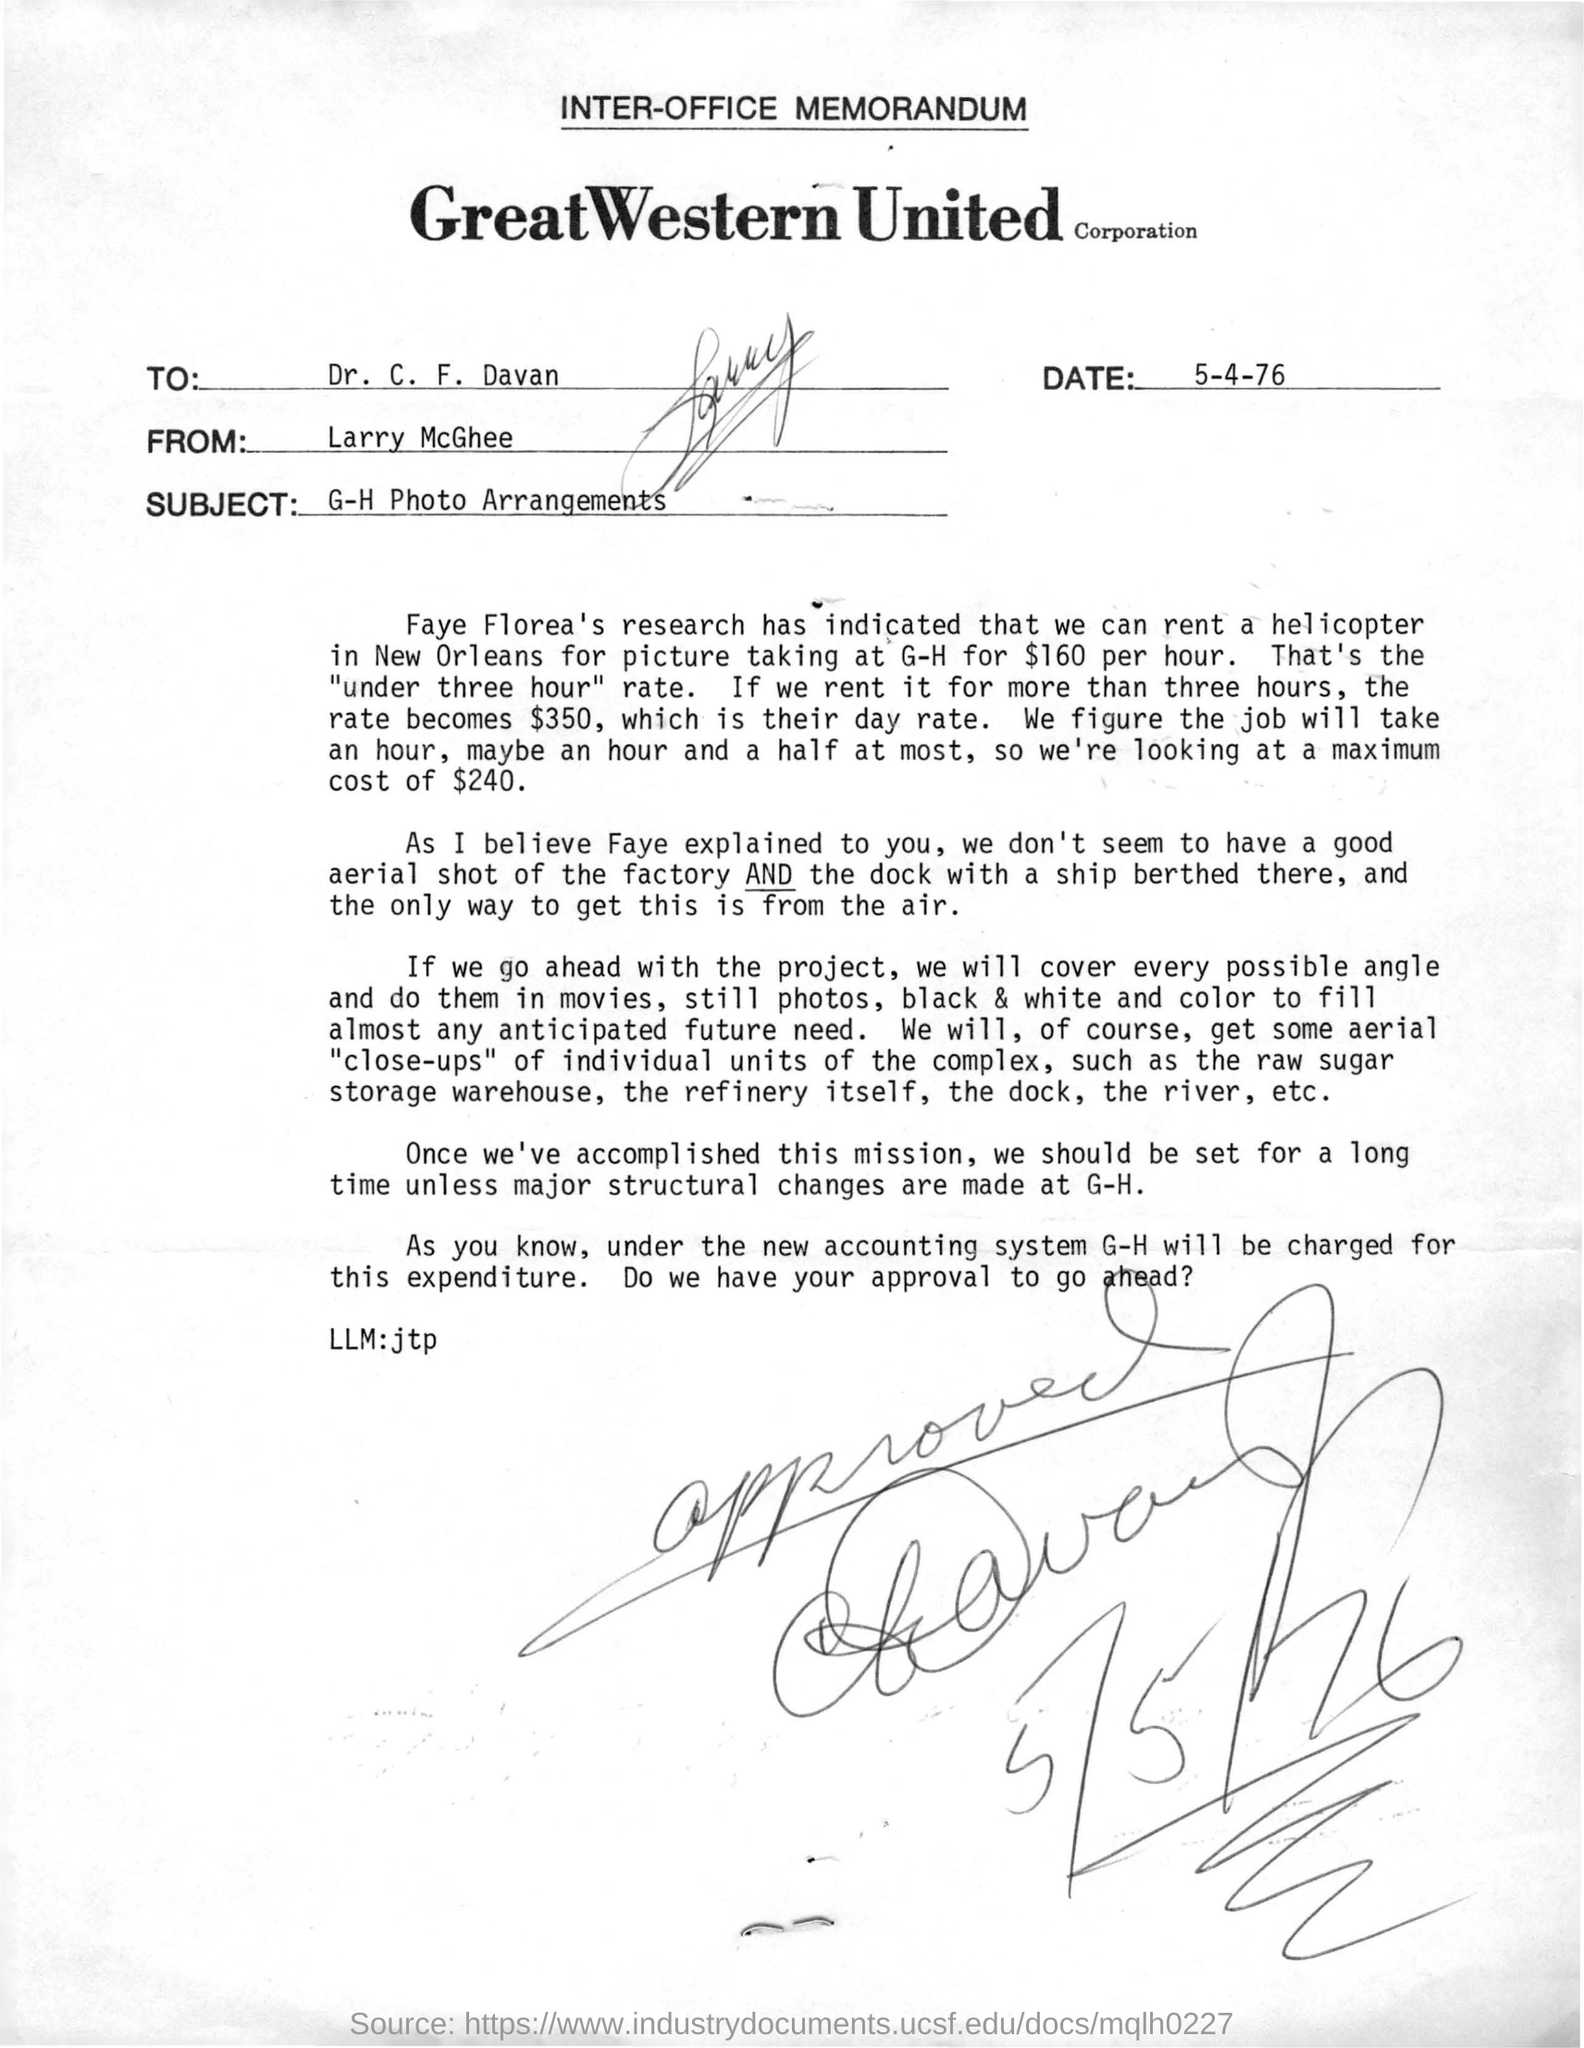Which place is mentioned in the memorandum from where the helicopter can be rented?
Keep it short and to the point. New orleans. Who is the memorandum from?
Your response must be concise. Larry McGhee. To Whom is this memorandum addressed to?
Offer a very short reply. Dr. C. F. Davan. When is the memorandum dated on?
Provide a short and direct response. 5-4-76. 